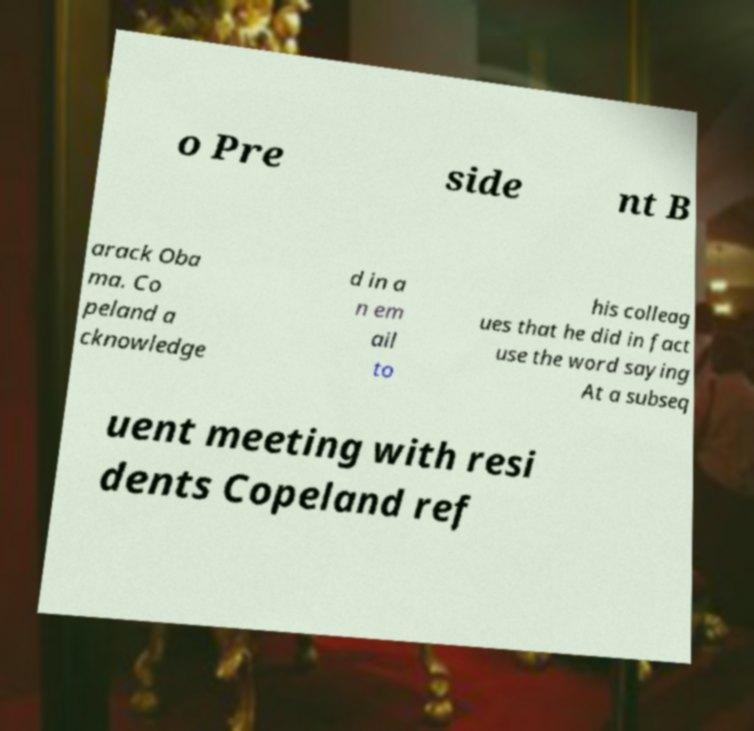There's text embedded in this image that I need extracted. Can you transcribe it verbatim? o Pre side nt B arack Oba ma. Co peland a cknowledge d in a n em ail to his colleag ues that he did in fact use the word saying At a subseq uent meeting with resi dents Copeland ref 